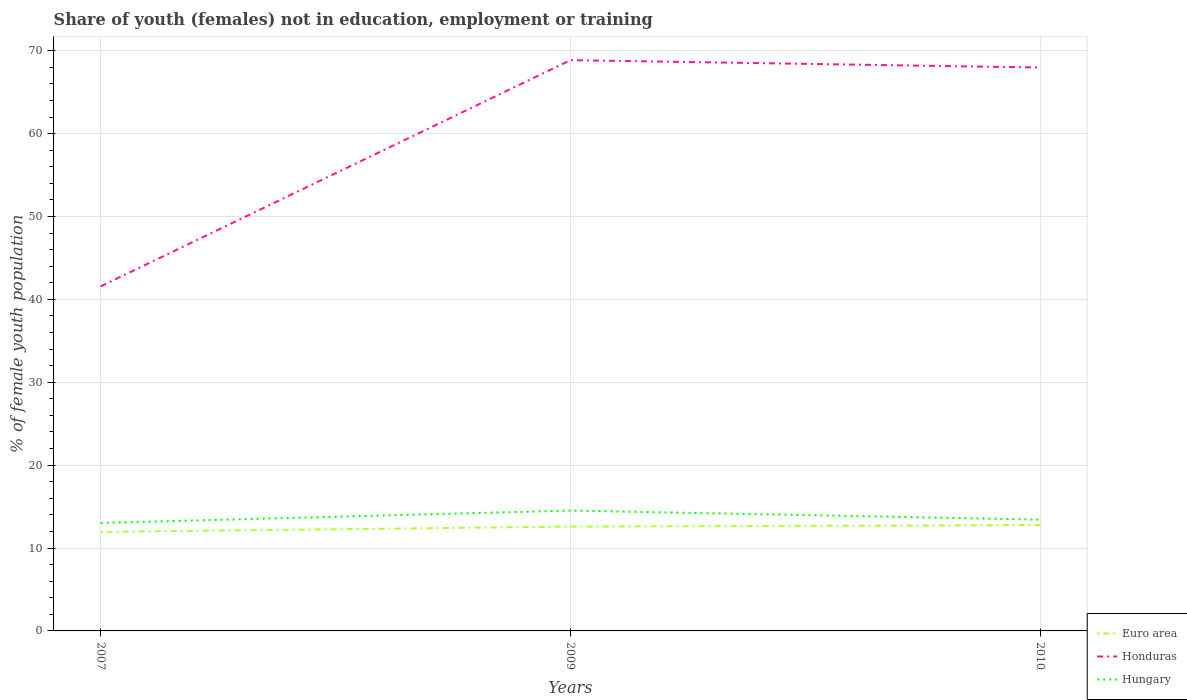How many different coloured lines are there?
Give a very brief answer. 3. Does the line corresponding to Euro area intersect with the line corresponding to Hungary?
Keep it short and to the point. No. Is the number of lines equal to the number of legend labels?
Offer a terse response. Yes. Across all years, what is the maximum percentage of unemployed female population in in Hungary?
Offer a terse response. 13.03. What is the total percentage of unemployed female population in in Hungary in the graph?
Give a very brief answer. -0.4. What is the difference between the highest and the second highest percentage of unemployed female population in in Euro area?
Give a very brief answer. 0.83. What is the difference between two consecutive major ticks on the Y-axis?
Your response must be concise. 10. Does the graph contain grids?
Your answer should be compact. Yes. Where does the legend appear in the graph?
Your answer should be very brief. Bottom right. What is the title of the graph?
Provide a short and direct response. Share of youth (females) not in education, employment or training. Does "Australia" appear as one of the legend labels in the graph?
Give a very brief answer. No. What is the label or title of the X-axis?
Provide a succinct answer. Years. What is the label or title of the Y-axis?
Provide a succinct answer. % of female youth population. What is the % of female youth population of Euro area in 2007?
Your answer should be compact. 11.94. What is the % of female youth population in Honduras in 2007?
Keep it short and to the point. 41.57. What is the % of female youth population of Hungary in 2007?
Keep it short and to the point. 13.03. What is the % of female youth population of Euro area in 2009?
Your response must be concise. 12.59. What is the % of female youth population in Honduras in 2009?
Give a very brief answer. 68.86. What is the % of female youth population in Hungary in 2009?
Your answer should be very brief. 14.52. What is the % of female youth population of Euro area in 2010?
Make the answer very short. 12.78. What is the % of female youth population in Honduras in 2010?
Provide a short and direct response. 67.97. What is the % of female youth population in Hungary in 2010?
Your response must be concise. 13.43. Across all years, what is the maximum % of female youth population in Euro area?
Provide a succinct answer. 12.78. Across all years, what is the maximum % of female youth population in Honduras?
Your response must be concise. 68.86. Across all years, what is the maximum % of female youth population of Hungary?
Give a very brief answer. 14.52. Across all years, what is the minimum % of female youth population of Euro area?
Your response must be concise. 11.94. Across all years, what is the minimum % of female youth population of Honduras?
Make the answer very short. 41.57. Across all years, what is the minimum % of female youth population of Hungary?
Make the answer very short. 13.03. What is the total % of female youth population of Euro area in the graph?
Provide a short and direct response. 37.31. What is the total % of female youth population in Honduras in the graph?
Give a very brief answer. 178.4. What is the total % of female youth population of Hungary in the graph?
Make the answer very short. 40.98. What is the difference between the % of female youth population in Euro area in 2007 and that in 2009?
Provide a short and direct response. -0.64. What is the difference between the % of female youth population of Honduras in 2007 and that in 2009?
Make the answer very short. -27.29. What is the difference between the % of female youth population in Hungary in 2007 and that in 2009?
Ensure brevity in your answer.  -1.49. What is the difference between the % of female youth population in Euro area in 2007 and that in 2010?
Offer a terse response. -0.83. What is the difference between the % of female youth population of Honduras in 2007 and that in 2010?
Make the answer very short. -26.4. What is the difference between the % of female youth population in Hungary in 2007 and that in 2010?
Give a very brief answer. -0.4. What is the difference between the % of female youth population in Euro area in 2009 and that in 2010?
Offer a terse response. -0.19. What is the difference between the % of female youth population of Honduras in 2009 and that in 2010?
Your answer should be very brief. 0.89. What is the difference between the % of female youth population in Hungary in 2009 and that in 2010?
Your answer should be very brief. 1.09. What is the difference between the % of female youth population of Euro area in 2007 and the % of female youth population of Honduras in 2009?
Your answer should be very brief. -56.92. What is the difference between the % of female youth population of Euro area in 2007 and the % of female youth population of Hungary in 2009?
Make the answer very short. -2.58. What is the difference between the % of female youth population of Honduras in 2007 and the % of female youth population of Hungary in 2009?
Your answer should be compact. 27.05. What is the difference between the % of female youth population in Euro area in 2007 and the % of female youth population in Honduras in 2010?
Keep it short and to the point. -56.03. What is the difference between the % of female youth population in Euro area in 2007 and the % of female youth population in Hungary in 2010?
Give a very brief answer. -1.49. What is the difference between the % of female youth population of Honduras in 2007 and the % of female youth population of Hungary in 2010?
Ensure brevity in your answer.  28.14. What is the difference between the % of female youth population of Euro area in 2009 and the % of female youth population of Honduras in 2010?
Your response must be concise. -55.38. What is the difference between the % of female youth population in Euro area in 2009 and the % of female youth population in Hungary in 2010?
Provide a succinct answer. -0.84. What is the difference between the % of female youth population in Honduras in 2009 and the % of female youth population in Hungary in 2010?
Provide a short and direct response. 55.43. What is the average % of female youth population of Euro area per year?
Provide a short and direct response. 12.44. What is the average % of female youth population of Honduras per year?
Keep it short and to the point. 59.47. What is the average % of female youth population of Hungary per year?
Offer a very short reply. 13.66. In the year 2007, what is the difference between the % of female youth population of Euro area and % of female youth population of Honduras?
Keep it short and to the point. -29.63. In the year 2007, what is the difference between the % of female youth population of Euro area and % of female youth population of Hungary?
Give a very brief answer. -1.09. In the year 2007, what is the difference between the % of female youth population of Honduras and % of female youth population of Hungary?
Your answer should be very brief. 28.54. In the year 2009, what is the difference between the % of female youth population in Euro area and % of female youth population in Honduras?
Offer a terse response. -56.27. In the year 2009, what is the difference between the % of female youth population of Euro area and % of female youth population of Hungary?
Make the answer very short. -1.93. In the year 2009, what is the difference between the % of female youth population in Honduras and % of female youth population in Hungary?
Give a very brief answer. 54.34. In the year 2010, what is the difference between the % of female youth population of Euro area and % of female youth population of Honduras?
Provide a succinct answer. -55.19. In the year 2010, what is the difference between the % of female youth population of Euro area and % of female youth population of Hungary?
Your answer should be very brief. -0.65. In the year 2010, what is the difference between the % of female youth population in Honduras and % of female youth population in Hungary?
Your answer should be very brief. 54.54. What is the ratio of the % of female youth population in Euro area in 2007 to that in 2009?
Provide a short and direct response. 0.95. What is the ratio of the % of female youth population of Honduras in 2007 to that in 2009?
Keep it short and to the point. 0.6. What is the ratio of the % of female youth population of Hungary in 2007 to that in 2009?
Offer a terse response. 0.9. What is the ratio of the % of female youth population in Euro area in 2007 to that in 2010?
Provide a succinct answer. 0.93. What is the ratio of the % of female youth population of Honduras in 2007 to that in 2010?
Give a very brief answer. 0.61. What is the ratio of the % of female youth population of Hungary in 2007 to that in 2010?
Provide a short and direct response. 0.97. What is the ratio of the % of female youth population in Euro area in 2009 to that in 2010?
Make the answer very short. 0.99. What is the ratio of the % of female youth population in Honduras in 2009 to that in 2010?
Your response must be concise. 1.01. What is the ratio of the % of female youth population in Hungary in 2009 to that in 2010?
Give a very brief answer. 1.08. What is the difference between the highest and the second highest % of female youth population of Euro area?
Keep it short and to the point. 0.19. What is the difference between the highest and the second highest % of female youth population of Honduras?
Offer a very short reply. 0.89. What is the difference between the highest and the second highest % of female youth population of Hungary?
Ensure brevity in your answer.  1.09. What is the difference between the highest and the lowest % of female youth population in Euro area?
Provide a short and direct response. 0.83. What is the difference between the highest and the lowest % of female youth population in Honduras?
Your answer should be compact. 27.29. What is the difference between the highest and the lowest % of female youth population of Hungary?
Your response must be concise. 1.49. 